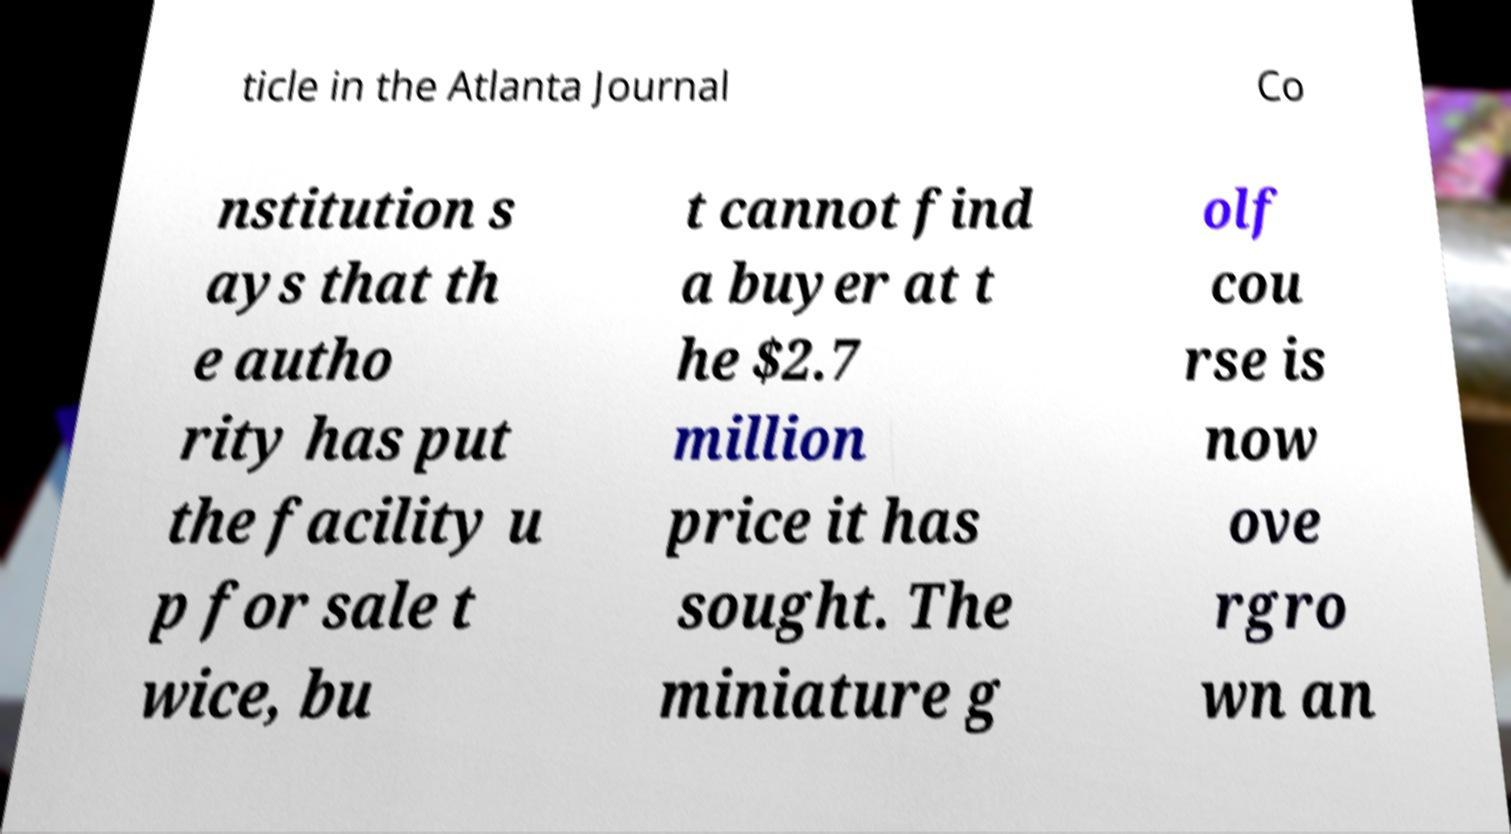Please identify and transcribe the text found in this image. ticle in the Atlanta Journal Co nstitution s ays that th e autho rity has put the facility u p for sale t wice, bu t cannot find a buyer at t he $2.7 million price it has sought. The miniature g olf cou rse is now ove rgro wn an 